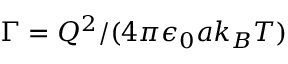Convert formula to latex. <formula><loc_0><loc_0><loc_500><loc_500>\Gamma = Q ^ { 2 } / ( 4 \pi \epsilon _ { 0 } a k _ { B } T )</formula> 